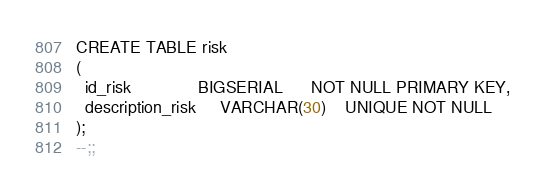<code> <loc_0><loc_0><loc_500><loc_500><_SQL_>CREATE TABLE risk
(
  id_risk              BIGSERIAL      NOT NULL PRIMARY KEY,
  description_risk     VARCHAR(30)    UNIQUE NOT NULL
);
--;;
</code> 